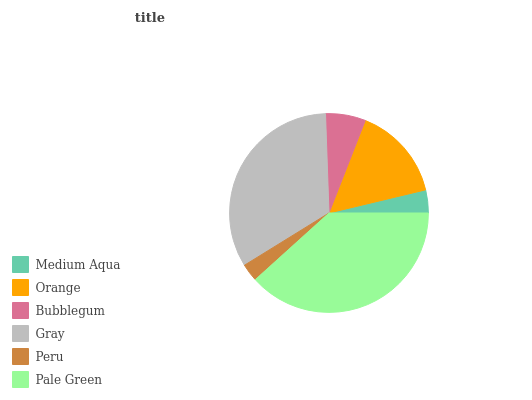Is Peru the minimum?
Answer yes or no. Yes. Is Pale Green the maximum?
Answer yes or no. Yes. Is Orange the minimum?
Answer yes or no. No. Is Orange the maximum?
Answer yes or no. No. Is Orange greater than Medium Aqua?
Answer yes or no. Yes. Is Medium Aqua less than Orange?
Answer yes or no. Yes. Is Medium Aqua greater than Orange?
Answer yes or no. No. Is Orange less than Medium Aqua?
Answer yes or no. No. Is Orange the high median?
Answer yes or no. Yes. Is Bubblegum the low median?
Answer yes or no. Yes. Is Peru the high median?
Answer yes or no. No. Is Medium Aqua the low median?
Answer yes or no. No. 